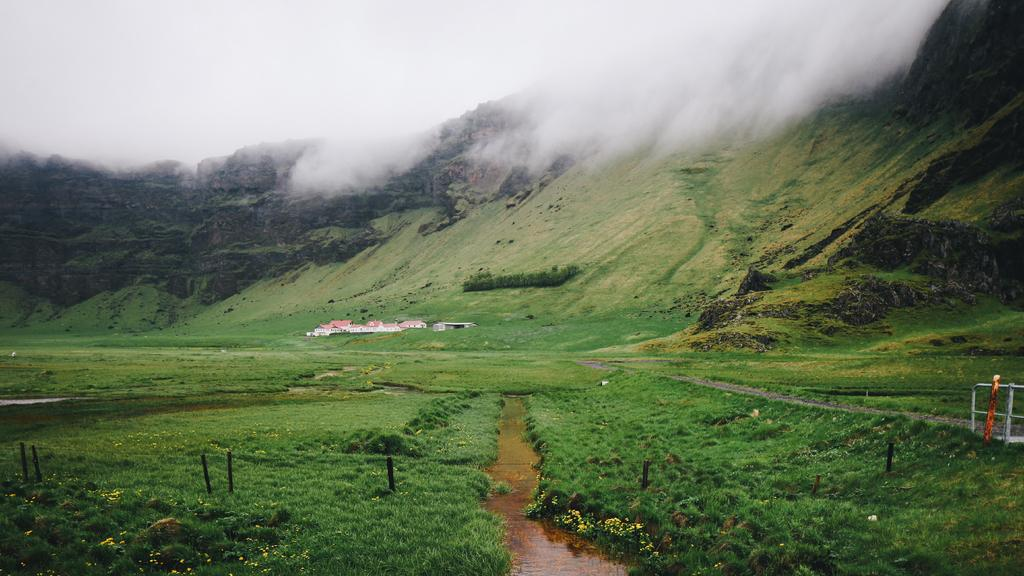What is visible in the center of the image? The sky is visible in the center of the image. How does the sky appear in the image? The sky appears smoky in the image. What type of landscape can be seen in the image? There are hills in the image, indicating a hilly landscape. What type of vegetation is present in the image? Grass and plants with flowers are present in the image. What type of structures are visible in the image? There are buildings in the image. What natural element is visible in the image? Water is visible in the image. What is located on the right side of the image? There is a fence on the right side of the image. What object is present on the right side of the image? There is one object on the right side of the image. What type of rhythm can be heard in the image? There is no sound or rhythm present in the image, as it is a still photograph. 